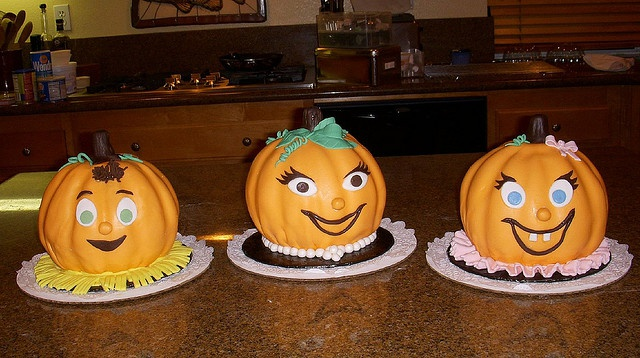Describe the objects in this image and their specific colors. I can see dining table in gold, maroon, black, and orange tones, cake in gold, orange, and red tones, cake in gold, orange, and red tones, cake in gold, orange, and lightgray tones, and oven in gold, black, gray, teal, and darkgray tones in this image. 